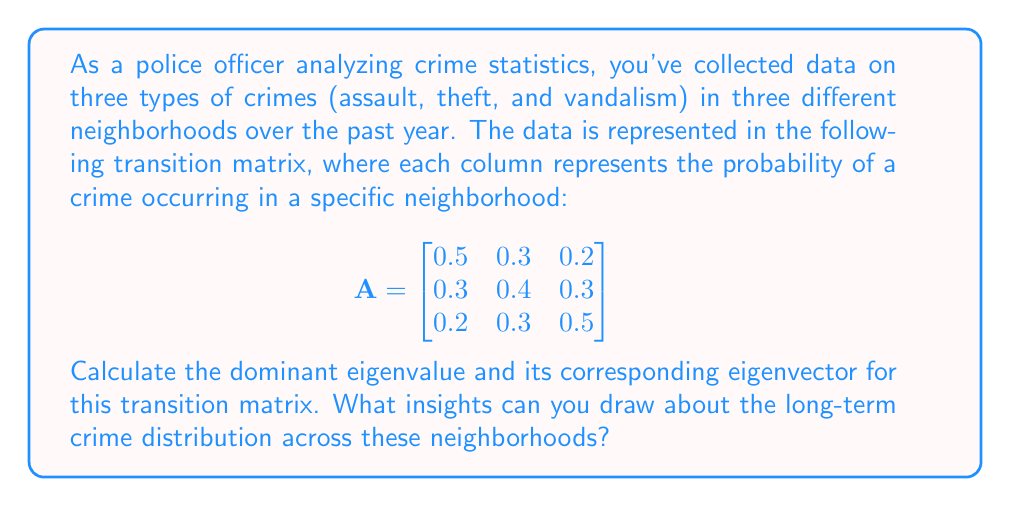Solve this math problem. To solve this problem, we need to follow these steps:

1. Find the characteristic equation of the matrix A.
2. Solve the characteristic equation to find the eigenvalues.
3. Identify the dominant eigenvalue (the largest one).
4. Find the eigenvector corresponding to the dominant eigenvalue.
5. Interpret the results.

Step 1: Find the characteristic equation
The characteristic equation is given by $det(A - \lambda I) = 0$, where $\lambda$ represents the eigenvalues.

$$det\begin{pmatrix}
0.5-\lambda & 0.3 & 0.2 \\
0.3 & 0.4-\lambda & 0.3 \\
0.2 & 0.3 & 0.5-\lambda
\end{pmatrix} = 0$$

Step 2: Solve the characteristic equation
Expanding the determinant:

$$(0.5-\lambda)((0.4-\lambda)(0.5-\lambda) - 0.09) - 0.3(0.3(0.5-\lambda) - 0.06) + 0.2(0.09 - 0.3(0.4-\lambda)) = 0$$

Simplifying:

$$-\lambda^3 + 1.4\lambda^2 - 0.47\lambda + 0.044 = 0$$

The roots of this equation are the eigenvalues. Using a calculator or computer algebra system, we find:

$\lambda_1 \approx 1$, $\lambda_2 \approx 0.2236$, $\lambda_3 \approx 0.1764$

Step 3: Identify the dominant eigenvalue
The dominant eigenvalue is the largest one: $\lambda_1 = 1$

Step 4: Find the eigenvector corresponding to the dominant eigenvalue
To find the eigenvector $\vec{v}$ corresponding to $\lambda_1 = 1$, we solve $(A - I)\vec{v} = \vec{0}$:

$$\begin{bmatrix}
-0.5 & 0.3 & 0.2 \\
0.3 & -0.6 & 0.3 \\
0.2 & 0.3 & -0.5
\end{bmatrix}\begin{bmatrix}
v_1 \\
v_2 \\
v_3
\end{bmatrix} = \begin{bmatrix}
0 \\
0 \\
0
\end{bmatrix}$$

Solving this system of equations, we find that the eigenvector is proportional to:

$$\vec{v} \approx \begin{bmatrix}
1 \\
1 \\
1
\end{bmatrix}$$

We can normalize this vector to get:

$$\vec{v} \approx \begin{bmatrix}
0.577 \\
0.577 \\
0.577
\end{bmatrix}$$

Step 5: Interpret the results
The dominant eigenvalue of 1 indicates that the system is in a steady state. The corresponding eigenvector represents the long-term distribution of crimes across the three neighborhoods.

The eigenvector shows that in the long run, crimes will be equally distributed among the three neighborhoods, with each neighborhood accounting for approximately 57.7% of each type of crime.
Answer: The dominant eigenvalue is 1, and its corresponding normalized eigenvector is approximately $[0.577, 0.577, 0.577]^T$. This indicates that in the long term, crimes will be equally distributed among the three neighborhoods, with each neighborhood accounting for about 57.7% of each type of crime. 